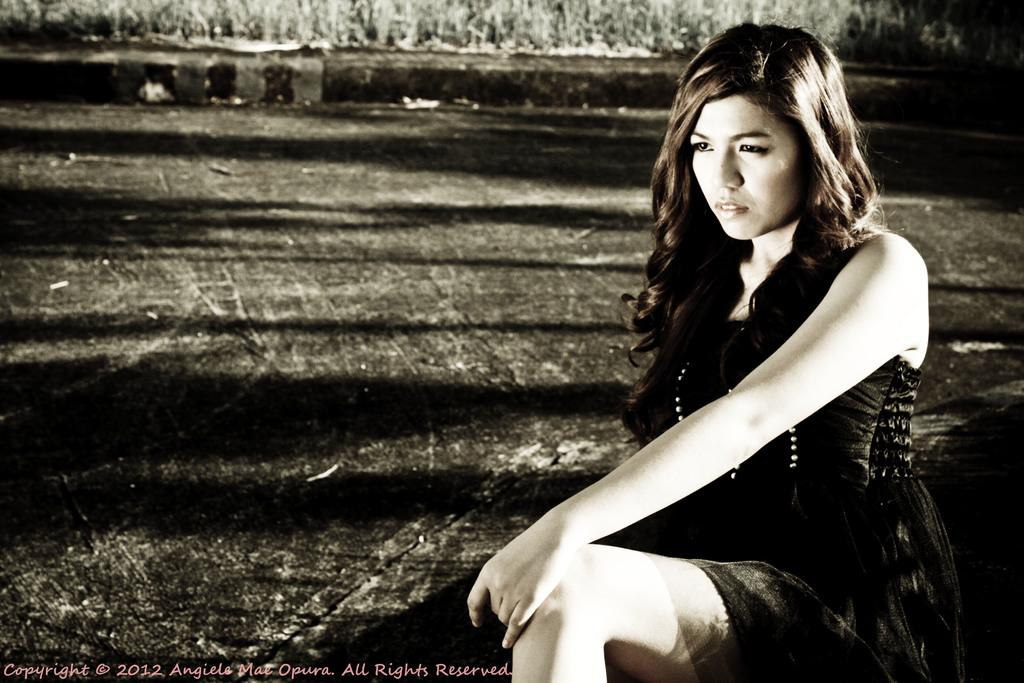What is the color scheme of the image? The image is black and white. What can be seen in the image? There is a woman sitting in the image. Is there any text present in the image? Yes, there is text at the bottom of the image. How many colorful things can be seen in the image? There are no colorful things present in the image, as it is black and white. What type of note is the woman holding in the image? There is no note visible in the image; the woman is simply sitting. 